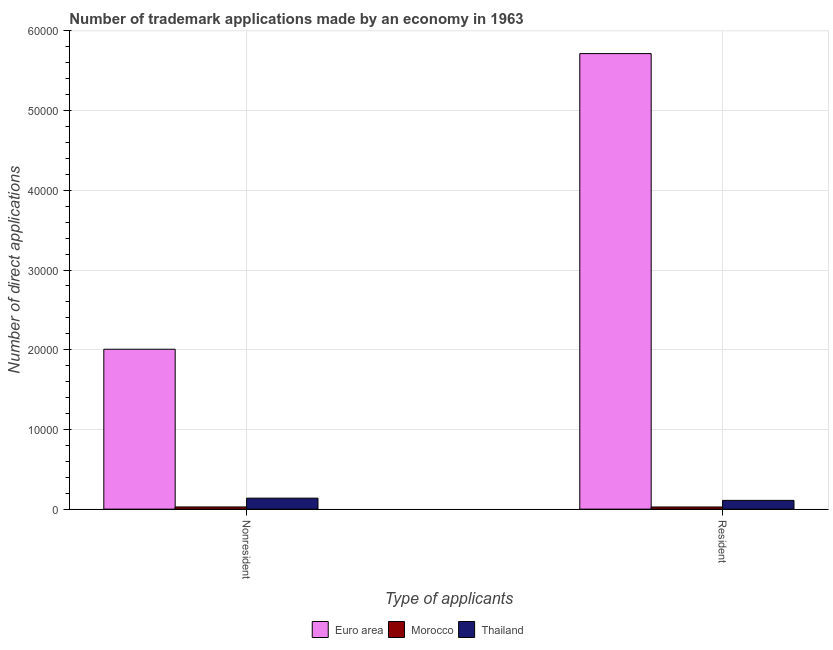Are the number of bars per tick equal to the number of legend labels?
Provide a succinct answer. Yes. Are the number of bars on each tick of the X-axis equal?
Ensure brevity in your answer.  Yes. How many bars are there on the 2nd tick from the right?
Your answer should be compact. 3. What is the label of the 1st group of bars from the left?
Your answer should be compact. Nonresident. What is the number of trademark applications made by non residents in Thailand?
Your answer should be very brief. 1380. Across all countries, what is the maximum number of trademark applications made by residents?
Provide a short and direct response. 5.72e+04. Across all countries, what is the minimum number of trademark applications made by residents?
Your response must be concise. 273. In which country was the number of trademark applications made by non residents minimum?
Give a very brief answer. Morocco. What is the total number of trademark applications made by non residents in the graph?
Ensure brevity in your answer.  2.17e+04. What is the difference between the number of trademark applications made by non residents in Morocco and that in Thailand?
Offer a very short reply. -1104. What is the difference between the number of trademark applications made by non residents in Morocco and the number of trademark applications made by residents in Euro area?
Keep it short and to the point. -5.69e+04. What is the average number of trademark applications made by non residents per country?
Offer a very short reply. 7239.67. What is the difference between the number of trademark applications made by non residents and number of trademark applications made by residents in Morocco?
Offer a very short reply. 3. What is the ratio of the number of trademark applications made by residents in Euro area to that in Morocco?
Make the answer very short. 209.36. Is the number of trademark applications made by non residents in Thailand less than that in Euro area?
Ensure brevity in your answer.  Yes. In how many countries, is the number of trademark applications made by residents greater than the average number of trademark applications made by residents taken over all countries?
Offer a very short reply. 1. What does the 1st bar from the right in Resident represents?
Offer a terse response. Thailand. Are all the bars in the graph horizontal?
Offer a terse response. No. Are the values on the major ticks of Y-axis written in scientific E-notation?
Provide a succinct answer. No. Where does the legend appear in the graph?
Your answer should be very brief. Bottom center. What is the title of the graph?
Provide a short and direct response. Number of trademark applications made by an economy in 1963. Does "Iceland" appear as one of the legend labels in the graph?
Give a very brief answer. No. What is the label or title of the X-axis?
Keep it short and to the point. Type of applicants. What is the label or title of the Y-axis?
Your answer should be very brief. Number of direct applications. What is the Number of direct applications in Euro area in Nonresident?
Your response must be concise. 2.01e+04. What is the Number of direct applications in Morocco in Nonresident?
Keep it short and to the point. 276. What is the Number of direct applications in Thailand in Nonresident?
Offer a very short reply. 1380. What is the Number of direct applications of Euro area in Resident?
Ensure brevity in your answer.  5.72e+04. What is the Number of direct applications in Morocco in Resident?
Make the answer very short. 273. What is the Number of direct applications in Thailand in Resident?
Provide a short and direct response. 1099. Across all Type of applicants, what is the maximum Number of direct applications in Euro area?
Offer a very short reply. 5.72e+04. Across all Type of applicants, what is the maximum Number of direct applications of Morocco?
Give a very brief answer. 276. Across all Type of applicants, what is the maximum Number of direct applications in Thailand?
Make the answer very short. 1380. Across all Type of applicants, what is the minimum Number of direct applications of Euro area?
Keep it short and to the point. 2.01e+04. Across all Type of applicants, what is the minimum Number of direct applications in Morocco?
Offer a terse response. 273. Across all Type of applicants, what is the minimum Number of direct applications of Thailand?
Keep it short and to the point. 1099. What is the total Number of direct applications of Euro area in the graph?
Your answer should be compact. 7.72e+04. What is the total Number of direct applications of Morocco in the graph?
Make the answer very short. 549. What is the total Number of direct applications in Thailand in the graph?
Offer a terse response. 2479. What is the difference between the Number of direct applications of Euro area in Nonresident and that in Resident?
Offer a very short reply. -3.71e+04. What is the difference between the Number of direct applications in Thailand in Nonresident and that in Resident?
Your response must be concise. 281. What is the difference between the Number of direct applications in Euro area in Nonresident and the Number of direct applications in Morocco in Resident?
Your answer should be very brief. 1.98e+04. What is the difference between the Number of direct applications in Euro area in Nonresident and the Number of direct applications in Thailand in Resident?
Give a very brief answer. 1.90e+04. What is the difference between the Number of direct applications of Morocco in Nonresident and the Number of direct applications of Thailand in Resident?
Provide a short and direct response. -823. What is the average Number of direct applications in Euro area per Type of applicants?
Your answer should be compact. 3.86e+04. What is the average Number of direct applications in Morocco per Type of applicants?
Offer a very short reply. 274.5. What is the average Number of direct applications in Thailand per Type of applicants?
Provide a succinct answer. 1239.5. What is the difference between the Number of direct applications in Euro area and Number of direct applications in Morocco in Nonresident?
Offer a very short reply. 1.98e+04. What is the difference between the Number of direct applications in Euro area and Number of direct applications in Thailand in Nonresident?
Make the answer very short. 1.87e+04. What is the difference between the Number of direct applications of Morocco and Number of direct applications of Thailand in Nonresident?
Give a very brief answer. -1104. What is the difference between the Number of direct applications in Euro area and Number of direct applications in Morocco in Resident?
Your answer should be very brief. 5.69e+04. What is the difference between the Number of direct applications in Euro area and Number of direct applications in Thailand in Resident?
Provide a succinct answer. 5.61e+04. What is the difference between the Number of direct applications of Morocco and Number of direct applications of Thailand in Resident?
Provide a succinct answer. -826. What is the ratio of the Number of direct applications of Euro area in Nonresident to that in Resident?
Provide a short and direct response. 0.35. What is the ratio of the Number of direct applications in Thailand in Nonresident to that in Resident?
Provide a succinct answer. 1.26. What is the difference between the highest and the second highest Number of direct applications of Euro area?
Your response must be concise. 3.71e+04. What is the difference between the highest and the second highest Number of direct applications in Thailand?
Your response must be concise. 281. What is the difference between the highest and the lowest Number of direct applications of Euro area?
Keep it short and to the point. 3.71e+04. What is the difference between the highest and the lowest Number of direct applications of Morocco?
Ensure brevity in your answer.  3. What is the difference between the highest and the lowest Number of direct applications in Thailand?
Offer a terse response. 281. 